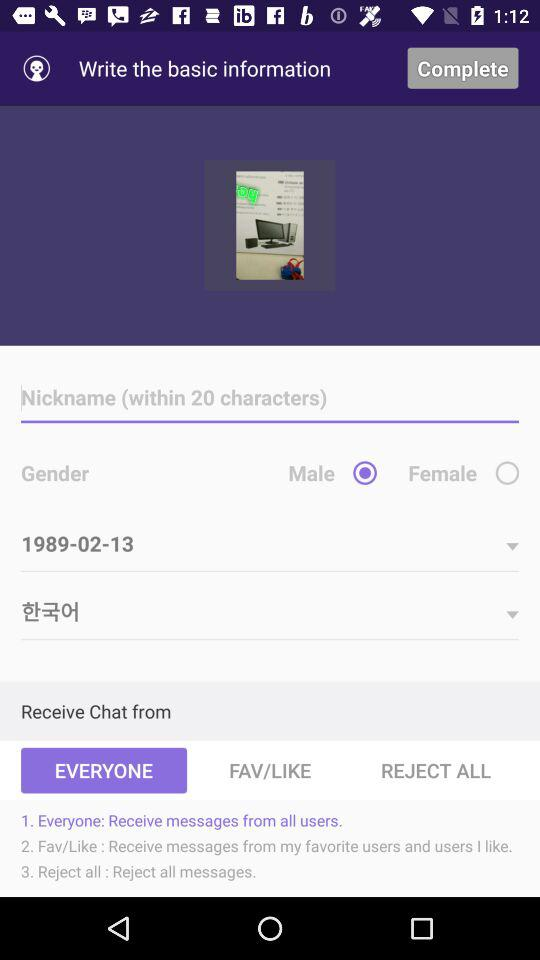What is the selected gender? The selected gender is "Male". 